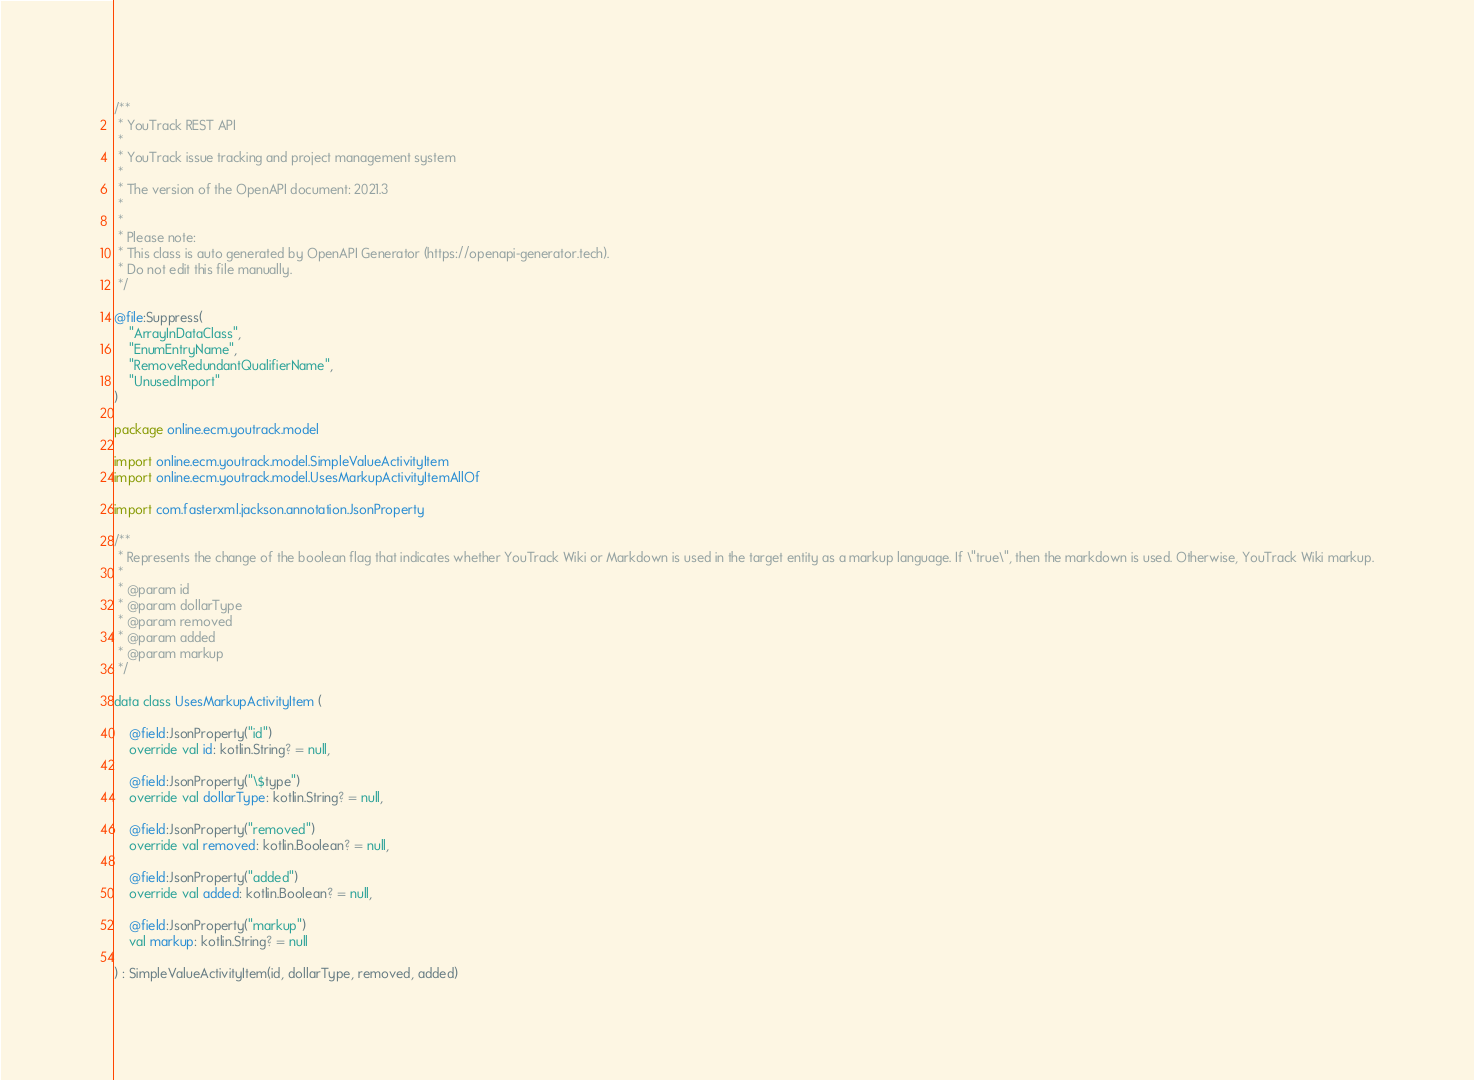Convert code to text. <code><loc_0><loc_0><loc_500><loc_500><_Kotlin_>/**
 * YouTrack REST API
 *
 * YouTrack issue tracking and project management system
 *
 * The version of the OpenAPI document: 2021.3
 * 
 *
 * Please note:
 * This class is auto generated by OpenAPI Generator (https://openapi-generator.tech).
 * Do not edit this file manually.
 */

@file:Suppress(
    "ArrayInDataClass",
    "EnumEntryName",
    "RemoveRedundantQualifierName",
    "UnusedImport"
)

package online.ecm.youtrack.model

import online.ecm.youtrack.model.SimpleValueActivityItem
import online.ecm.youtrack.model.UsesMarkupActivityItemAllOf

import com.fasterxml.jackson.annotation.JsonProperty

/**
 * Represents the change of the boolean flag that indicates whether YouTrack Wiki or Markdown is used in the target entity as a markup language. If \"true\", then the markdown is used. Otherwise, YouTrack Wiki markup.
 *
 * @param id 
 * @param dollarType 
 * @param removed 
 * @param added 
 * @param markup 
 */

data class UsesMarkupActivityItem (

    @field:JsonProperty("id")
    override val id: kotlin.String? = null,

    @field:JsonProperty("\$type")
    override val dollarType: kotlin.String? = null,

    @field:JsonProperty("removed")
    override val removed: kotlin.Boolean? = null,

    @field:JsonProperty("added")
    override val added: kotlin.Boolean? = null,

    @field:JsonProperty("markup")
    val markup: kotlin.String? = null

) : SimpleValueActivityItem(id, dollarType, removed, added)

</code> 